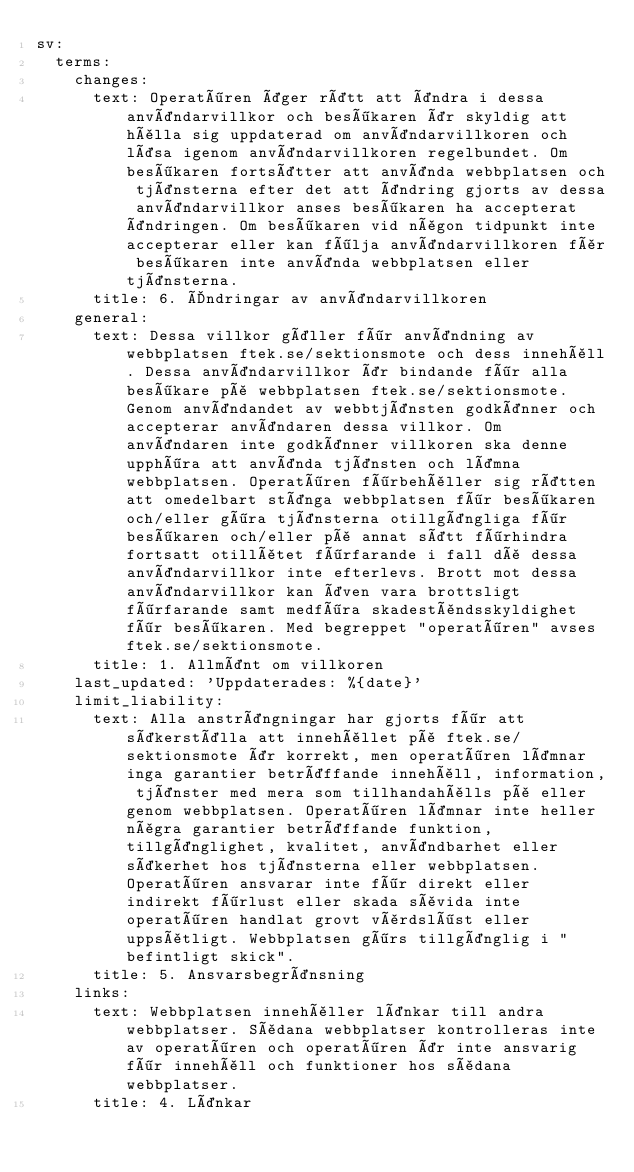Convert code to text. <code><loc_0><loc_0><loc_500><loc_500><_YAML_>sv:
  terms:
    changes:
      text: Operatören äger rätt att ändra i dessa användarvillkor och besökaren är skyldig att hålla sig uppdaterad om användarvillkoren och läsa igenom användarvillkoren regelbundet. Om besökaren fortsätter att använda webbplatsen och tjänsterna efter det att ändring gjorts av dessa användarvillkor anses besökaren ha accepterat ändringen. Om besökaren vid någon tidpunkt inte accepterar eller kan följa användarvillkoren får besökaren inte använda webbplatsen eller tjänsterna.
      title: 6. Ändringar av användarvillkoren
    general:
      text: Dessa villkor gäller för användning av webbplatsen ftek.se/sektionsmote och dess innehåll. Dessa användarvillkor är bindande för alla besökare på webbplatsen ftek.se/sektionsmote. Genom användandet av webbtjänsten godkänner och accepterar användaren dessa villkor. Om användaren inte godkänner villkoren ska denne upphöra att använda tjänsten och lämna webbplatsen. Operatören förbehåller sig rätten att omedelbart stänga webbplatsen för besökaren och/eller göra tjänsterna otillgängliga för besökaren och/eller på annat sätt förhindra fortsatt otillåtet förfarande i fall då dessa användarvillkor inte efterlevs. Brott mot dessa användarvillkor kan även vara brottsligt förfarande samt medföra skadeståndsskyldighet för besökaren. Med begreppet "operatören" avses ftek.se/sektionsmote.
      title: 1. Allmänt om villkoren
    last_updated: 'Uppdaterades: %{date}'
    limit_liability:
      text: Alla ansträngningar har gjorts för att säkerställa att innehållet på ftek.se/sektionsmote är korrekt, men operatören lämnar inga garantier beträffande innehåll, information, tjänster med mera som tillhandahålls på eller genom webbplatsen. Operatören lämnar inte heller några garantier beträffande funktion, tillgänglighet, kvalitet, användbarhet eller säkerhet hos tjänsterna eller webbplatsen. Operatören ansvarar inte för direkt eller indirekt förlust eller skada såvida inte operatören handlat grovt vårdslöst eller uppsåtligt. Webbplatsen görs tillgänglig i "befintligt skick".
      title: 5. Ansvarsbegränsning
    links:
      text: Webbplatsen innehåller länkar till andra webbplatser. Sådana webbplatser kontrolleras inte av operatören och operatören är inte ansvarig för innehåll och funktioner hos sådana webbplatser.
      title: 4. Länkar</code> 